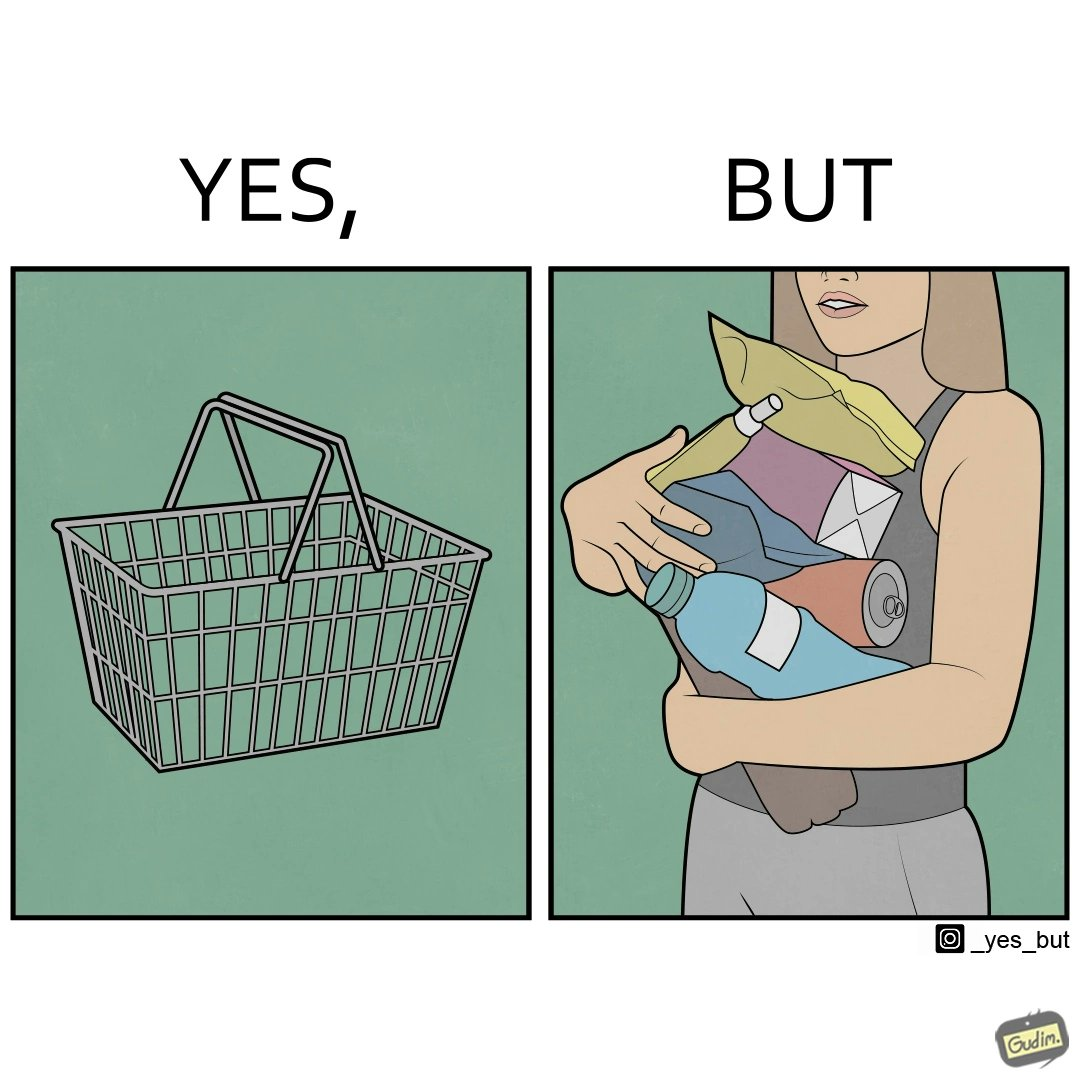What does this image depict? The image is ironic, because even when there are steel frame baskets are available at the supermarkets people prefer carrying the items in hand 